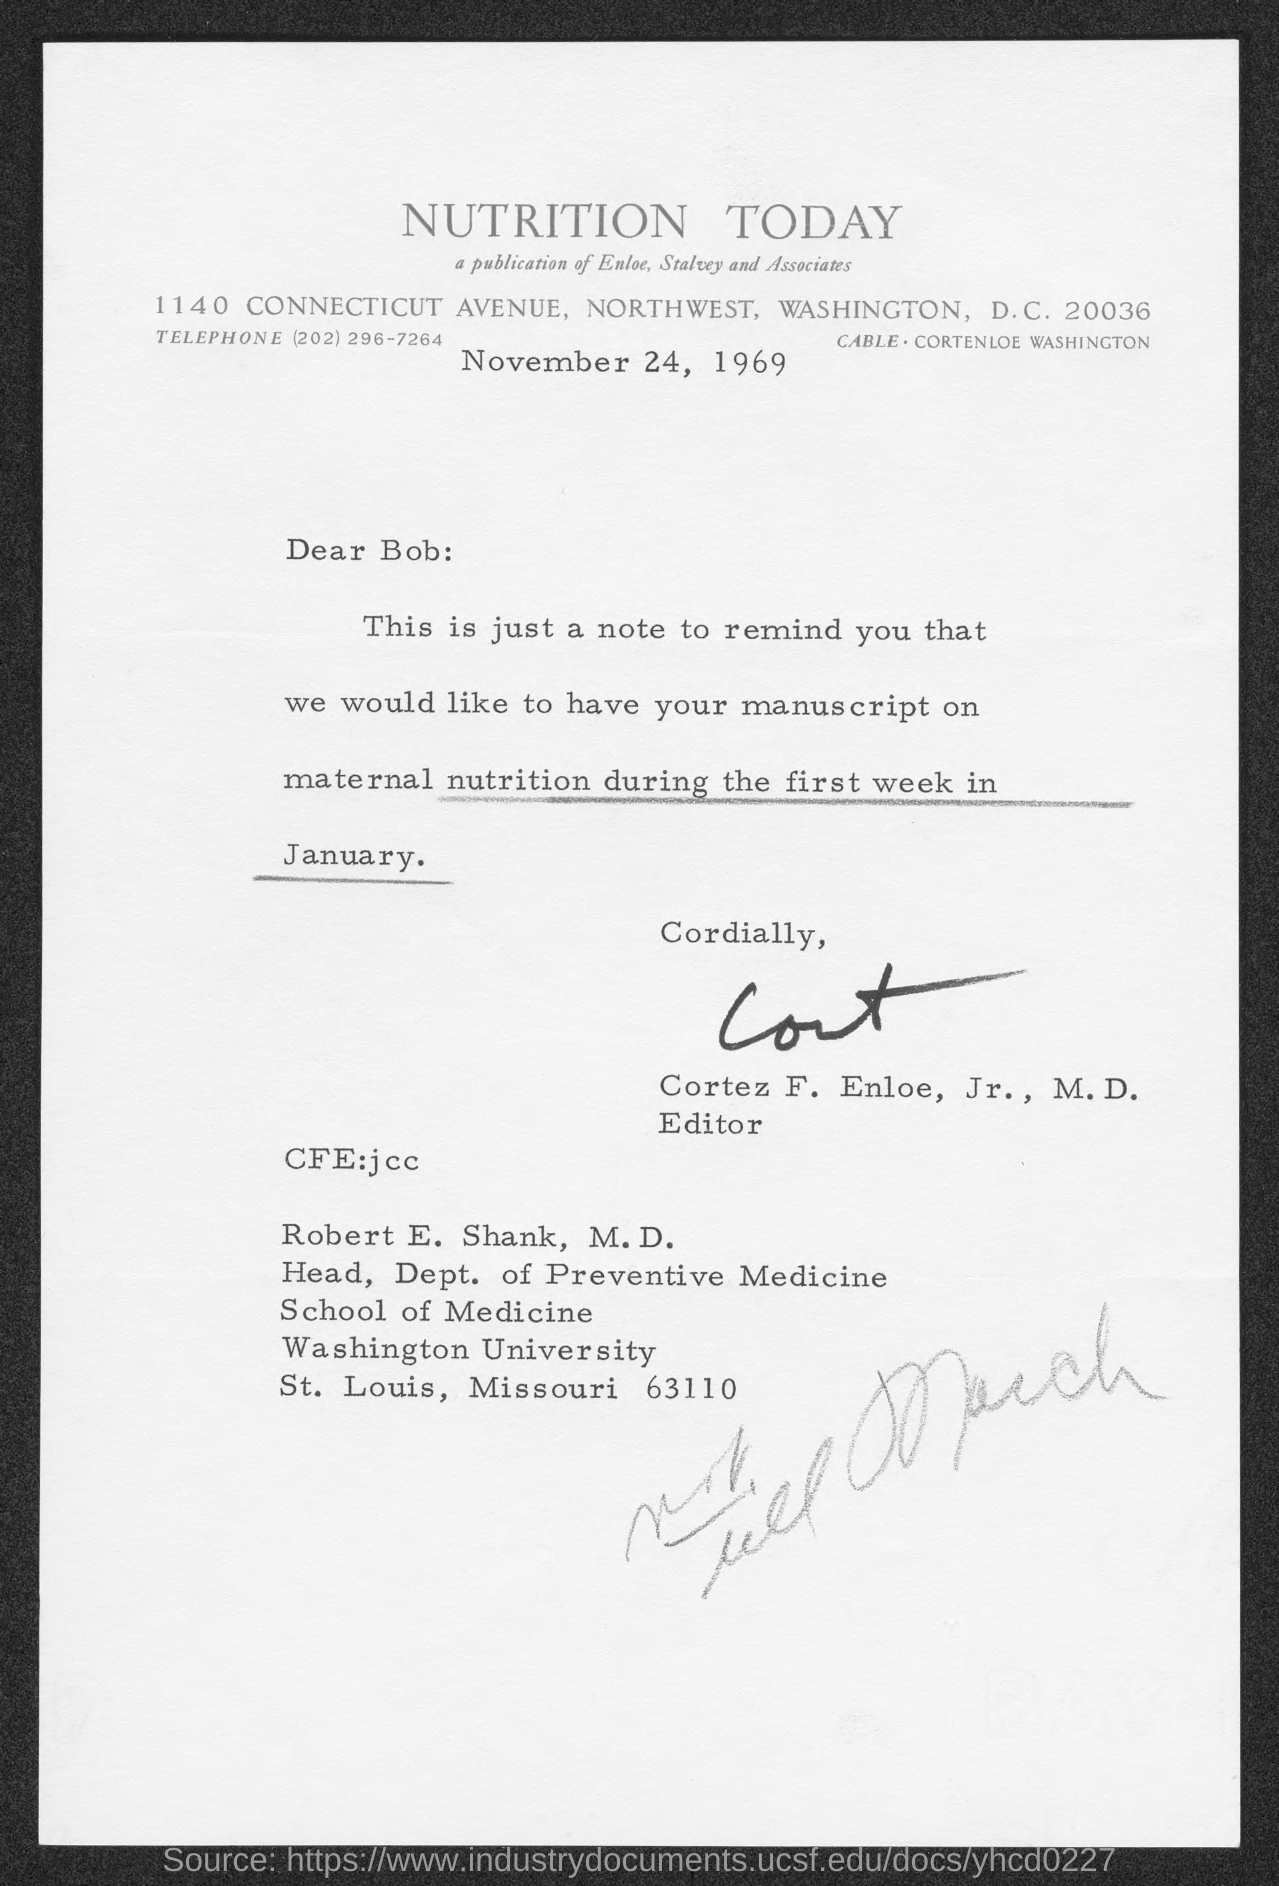What is the date mentioned in this letter?
Your answer should be very brief. November 24, 1969. 